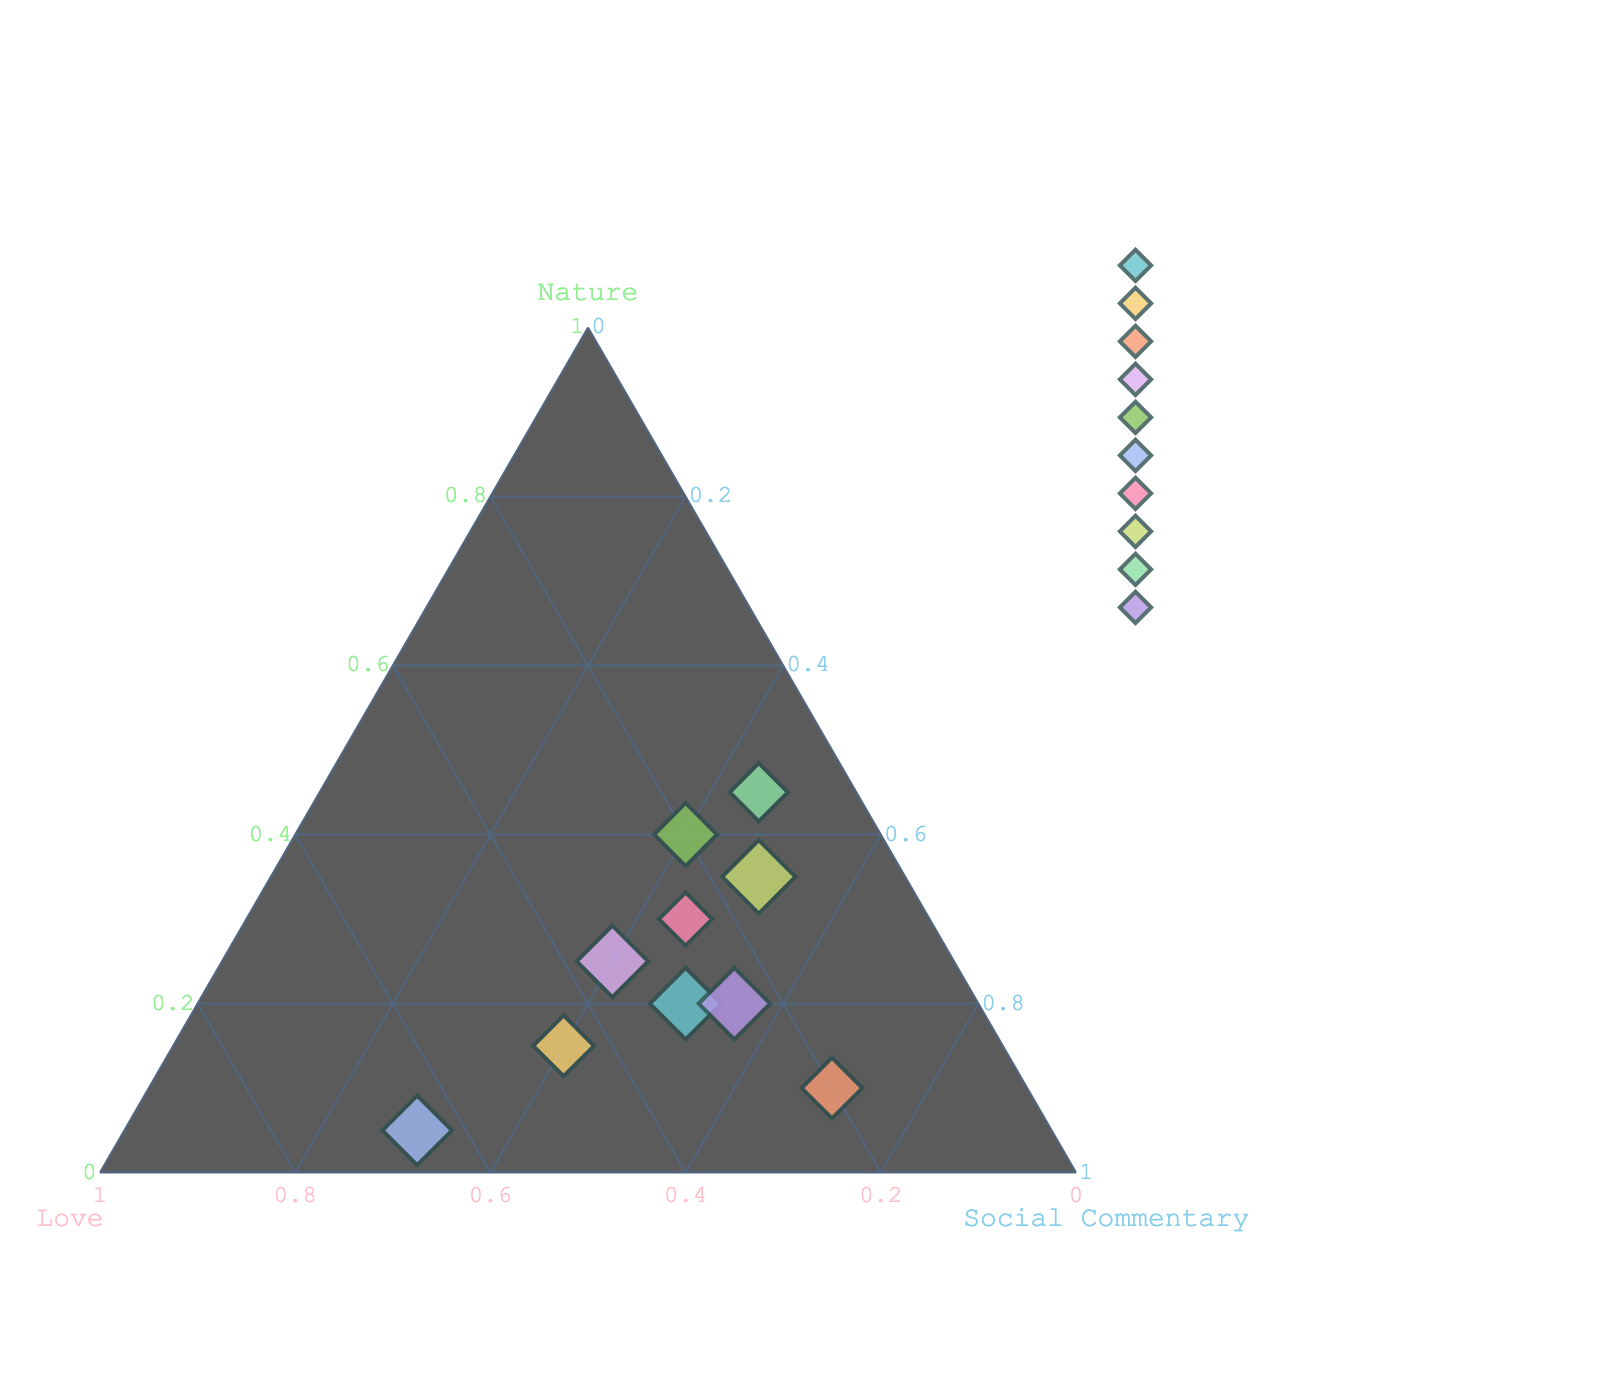What is the title of the ternary plot? The title is generally located at the top of the figure. It provides a summary of what the plot represents.
Answer: Balance of Themes in Poetry Collections Which collection is closest to having an equal balance of all three themes? To find this, look for the data point near the center of the ternary plot where the proportions of Nature, Love, and Social Commentary are almost equal.
Answer: Urban Verses How many poetry collections have Nature as the highest proportion among the three themes? Identify the data points positioned closer to the 'Nature' axis. Count these points.
Answer: 2 What is the highest proportion of Social Commentary found in any collection? Look for the collection with a data point closest to the 'Social Commentary' axis, which indicates the highest proportion of Social Commentary.
Answer: 70 Which collection has the highest proportion of Love? Identify the collection by looking at the data points closest to the 'Love' axis.
Answer: Love in the Breadline How do the themes in "Concrete Garden" compare with those in "Dumpster Diving Odes"? Examine the position of both data points on the ternary plot. Compare their relative distances from the three axes.
Answer: Concrete Garden: Higher Nature and Love but lower Social Commentary compared to Dumpster Diving Odes What is the sum of the proportions for "Spare Change Haiku"? Check the point corresponding to "Spare Change Haiku". Sum the proportions of Nature, Love, and Social Commentary.
Answer: 100 (35 + 15 + 50) Which collection has the smallest proportion of Nature, and what is that proportion? Look for the collection near the bottom edge of the Nature axis, indicating a small proportion of Nature.
Answer: Love in the Breadline, 5 Is there any collection that has a higher proportion of Social Commentary than "Whispers of Poverty"? Compare the proportion of Social Commentary for all collections with "Whispers of Poverty". One needs to find if any collection has more than 50% Social Commentary.
Answer: Yes, Starving Artist's Manifesto (70) Which collections are positioned closer to the 'Love' axis but not having it as their highest proportion? Identify collections placed near the ‘Love’ axis but verify if the highest proportion is not Love by comparing proportions with other themes.
Answer: Whispers of Poverty, Caffeine Dreams, Urban Verses, Concrete Garden 